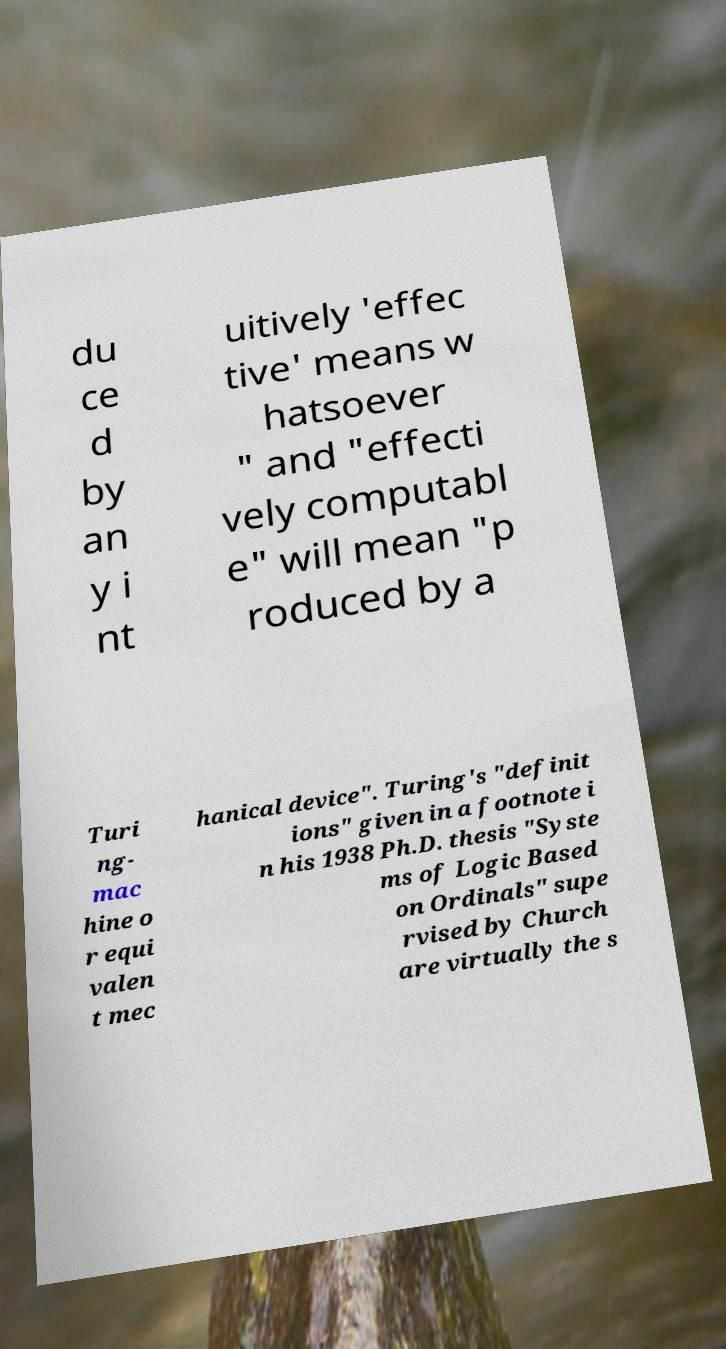Can you read and provide the text displayed in the image?This photo seems to have some interesting text. Can you extract and type it out for me? du ce d by an y i nt uitively 'effec tive' means w hatsoever " and "effecti vely computabl e" will mean "p roduced by a Turi ng- mac hine o r equi valen t mec hanical device". Turing's "definit ions" given in a footnote i n his 1938 Ph.D. thesis "Syste ms of Logic Based on Ordinals" supe rvised by Church are virtually the s 